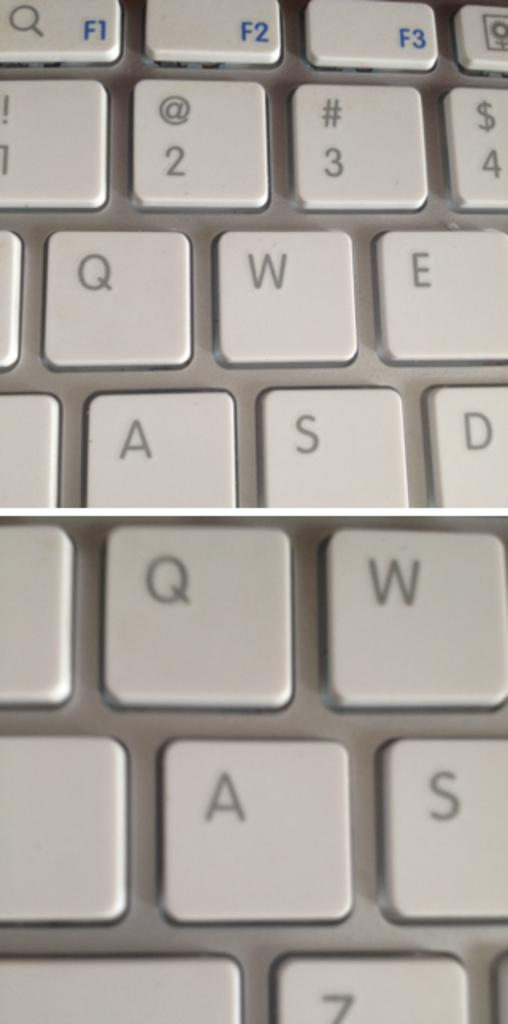<image>
Relay a brief, clear account of the picture shown. A computer keyboard has the letter W right next to the letter Q. 